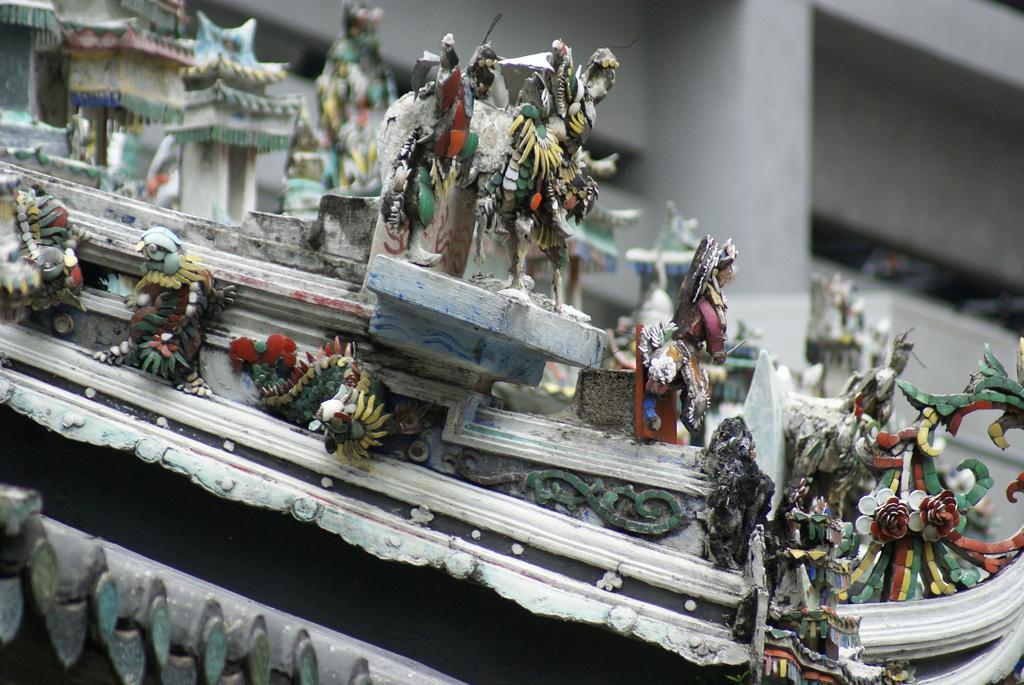In one or two sentences, can you explain what this image depicts? In this image we can see some showpieces. 